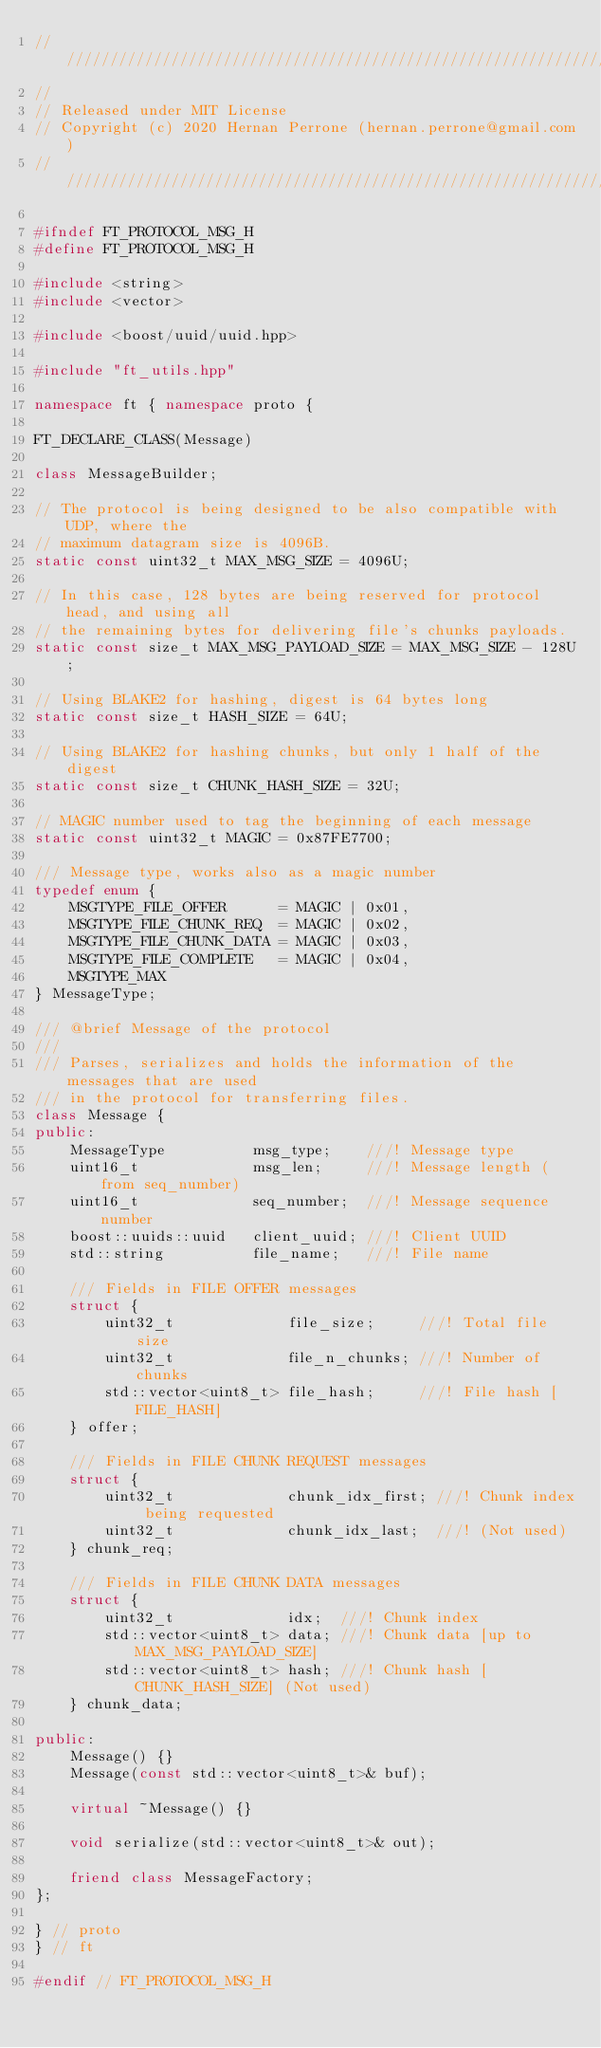Convert code to text. <code><loc_0><loc_0><loc_500><loc_500><_C++_>//////////////////////////////////////////////////////////////////////////////
//
// Released under MIT License
// Copyright (c) 2020 Hernan Perrone (hernan.perrone@gmail.com)
//////////////////////////////////////////////////////////////////////////////

#ifndef FT_PROTOCOL_MSG_H
#define FT_PROTOCOL_MSG_H

#include <string>
#include <vector>

#include <boost/uuid/uuid.hpp>

#include "ft_utils.hpp"

namespace ft { namespace proto {

FT_DECLARE_CLASS(Message)

class MessageBuilder;

// The protocol is being designed to be also compatible with UDP, where the
// maximum datagram size is 4096B.
static const uint32_t MAX_MSG_SIZE = 4096U;

// In this case, 128 bytes are being reserved for protocol head, and using all
// the remaining bytes for delivering file's chunks payloads.
static const size_t MAX_MSG_PAYLOAD_SIZE = MAX_MSG_SIZE - 128U;

// Using BLAKE2 for hashing, digest is 64 bytes long
static const size_t HASH_SIZE = 64U;

// Using BLAKE2 for hashing chunks, but only 1 half of the digest
static const size_t CHUNK_HASH_SIZE = 32U;

// MAGIC number used to tag the beginning of each message
static const uint32_t MAGIC = 0x87FE7700;

/// Message type, works also as a magic number
typedef enum {
	MSGTYPE_FILE_OFFER      = MAGIC | 0x01,
	MSGTYPE_FILE_CHUNK_REQ  = MAGIC | 0x02,
	MSGTYPE_FILE_CHUNK_DATA = MAGIC | 0x03,
	MSGTYPE_FILE_COMPLETE   = MAGIC | 0x04,
	MSGTYPE_MAX
} MessageType;

/// @brief Message of the protocol
///
/// Parses, serializes and holds the information of the messages that are used
/// in the protocol for transferring files.
class Message {
public:
	MessageType          msg_type;    ///! Message type
	uint16_t             msg_len;     ///! Message length (from seq_number)
	uint16_t             seq_number;  ///! Message sequence number
	boost::uuids::uuid   client_uuid; ///! Client UUID
	std::string          file_name;   ///! File name

	/// Fields in FILE OFFER messages
	struct {
		uint32_t             file_size;     ///! Total file size
		uint32_t             file_n_chunks; ///! Number of chunks
		std::vector<uint8_t> file_hash;     ///! File hash [FILE_HASH]
	} offer;

	/// Fields in FILE CHUNK REQUEST messages
	struct {
		uint32_t             chunk_idx_first; ///! Chunk index being requested
		uint32_t             chunk_idx_last;  ///! (Not used)
	} chunk_req;

	/// Fields in FILE CHUNK DATA messages
	struct {
		uint32_t             idx;  ///! Chunk index
		std::vector<uint8_t> data; ///! Chunk data [up to MAX_MSG_PAYLOAD_SIZE]
		std::vector<uint8_t> hash; ///! Chunk hash [CHUNK_HASH_SIZE] (Not used)
	} chunk_data;

public:
	Message() {}
	Message(const std::vector<uint8_t>& buf);

	virtual ~Message() {}

	void serialize(std::vector<uint8_t>& out);

	friend class MessageFactory;
};

} // proto
} // ft

#endif // FT_PROTOCOL_MSG_H</code> 